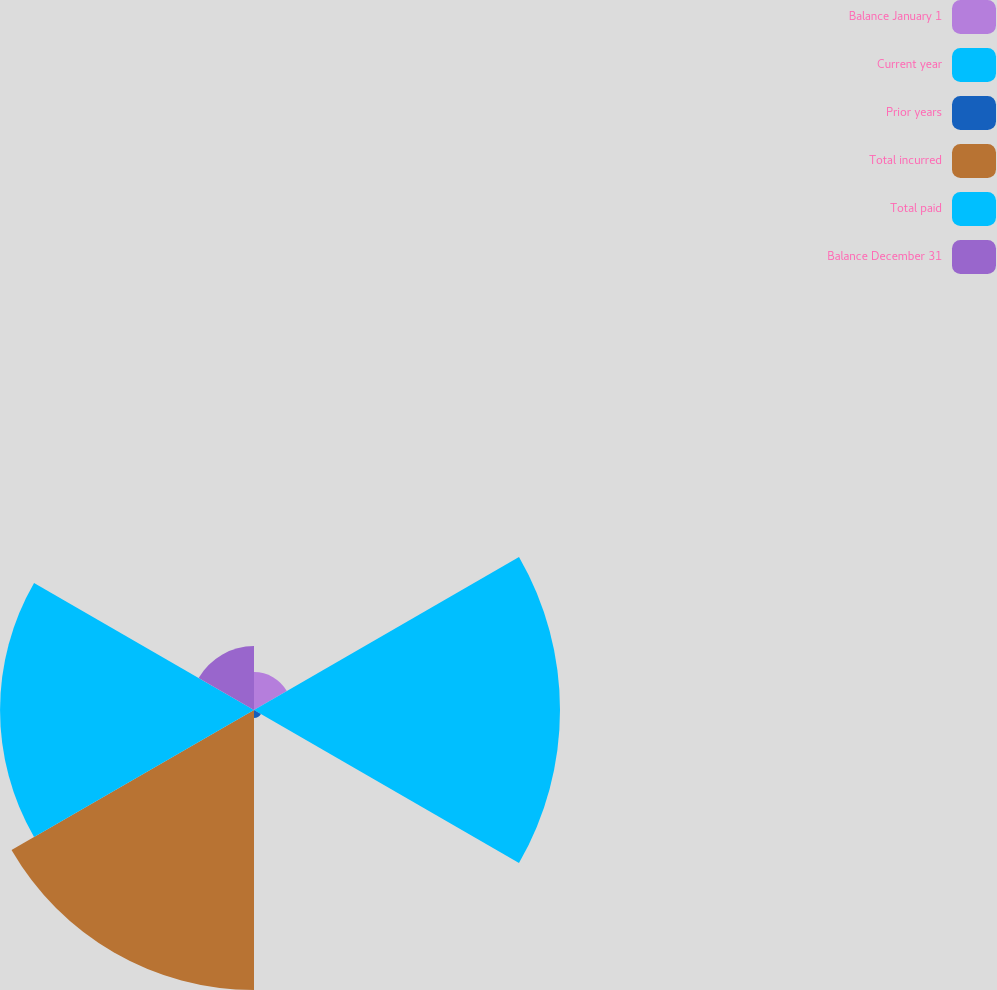<chart> <loc_0><loc_0><loc_500><loc_500><pie_chart><fcel>Balance January 1<fcel>Current year<fcel>Prior years<fcel>Total incurred<fcel>Total paid<fcel>Balance December 31<nl><fcel>3.99%<fcel>32.22%<fcel>0.84%<fcel>29.48%<fcel>26.74%<fcel>6.73%<nl></chart> 